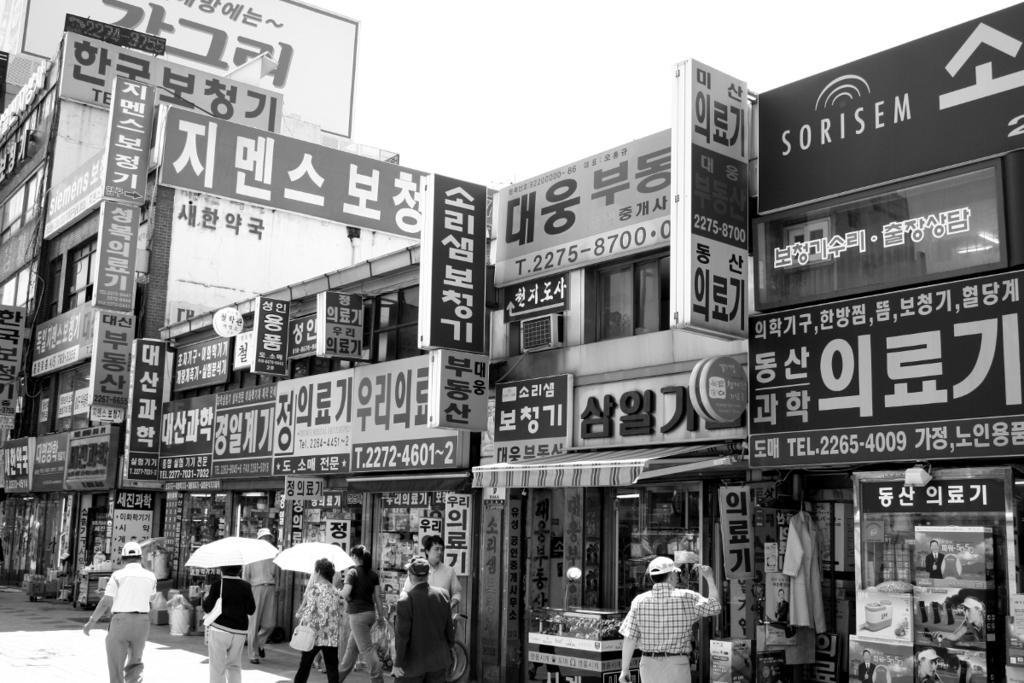Please provide a concise description of this image. In this image I can see in the middle two women are walking by holding the umbrellas, few other persons are also walking and there are stores with different advertising boards, at the top it is the sky. 